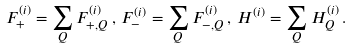Convert formula to latex. <formula><loc_0><loc_0><loc_500><loc_500>F _ { + } ^ { ( i ) } = \sum _ { Q } F _ { + , Q } ^ { ( i ) } \, , \, F _ { - } ^ { ( i ) } = \sum _ { Q } F _ { - , Q } ^ { ( i ) } \, , \, H ^ { ( i ) } = \sum _ { Q } H _ { Q } ^ { ( i ) } \, .</formula> 